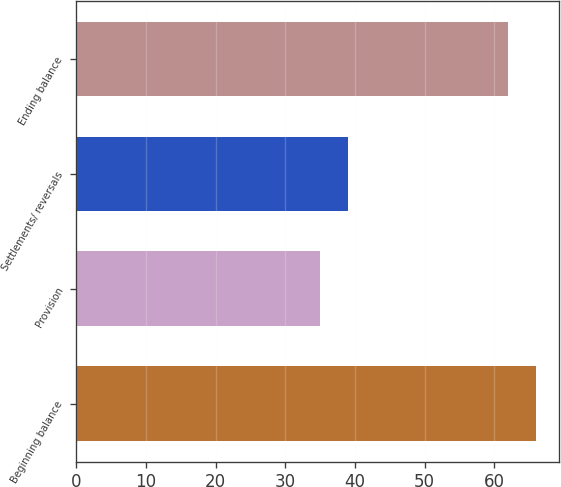Convert chart to OTSL. <chart><loc_0><loc_0><loc_500><loc_500><bar_chart><fcel>Beginning balance<fcel>Provision<fcel>Settlements/ reversals<fcel>Ending balance<nl><fcel>66<fcel>35<fcel>39<fcel>62<nl></chart> 